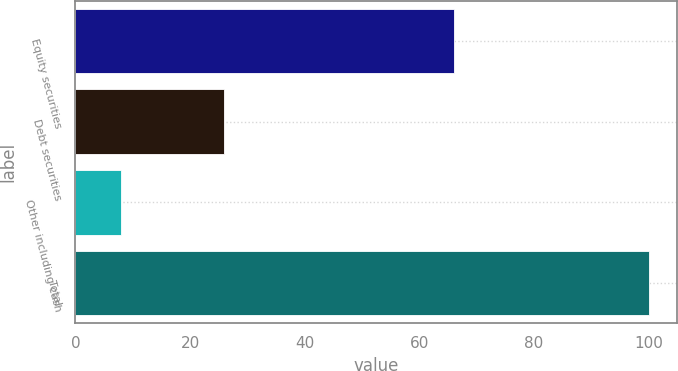<chart> <loc_0><loc_0><loc_500><loc_500><bar_chart><fcel>Equity securities<fcel>Debt securities<fcel>Other including cash<fcel>Total<nl><fcel>66<fcel>26<fcel>8<fcel>100<nl></chart> 